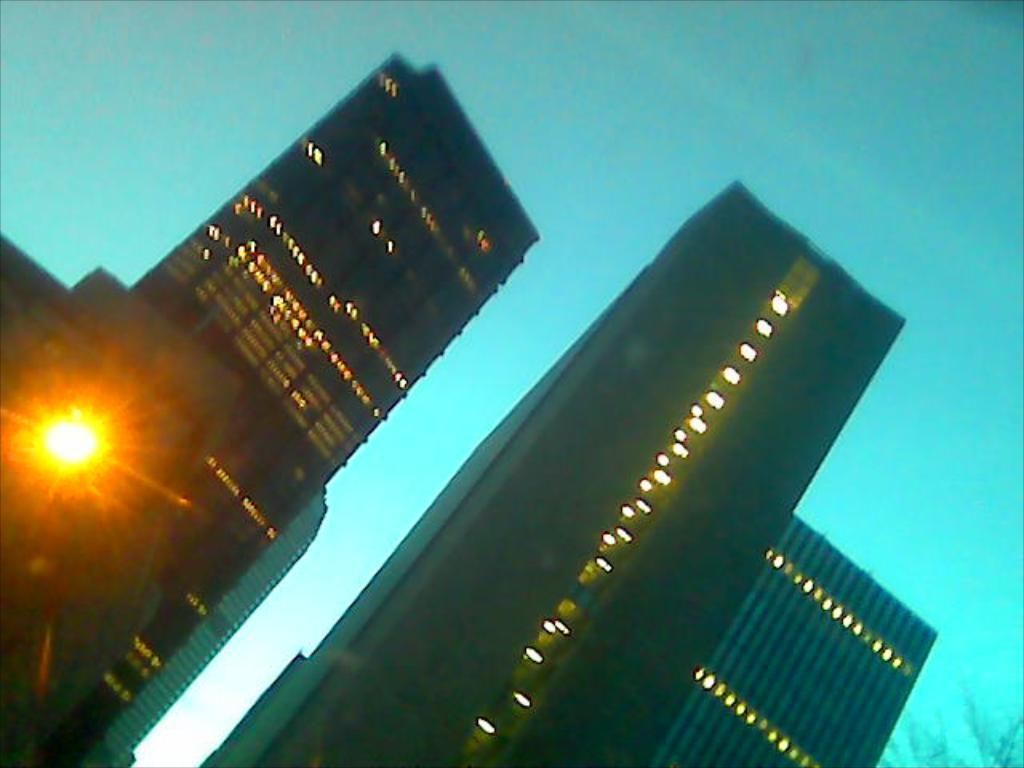What type of structures can be seen in the image? There are buildings in the image. What else is present in the image besides the buildings? There are lights and branches of a tree visible in the image. How would you describe the color of the sky in the image? The sky is pale blue in the image. Can you tell me how many grains of rice are on the ground in the image? There is no rice present in the image, so it is not possible to determine the number of grains. 